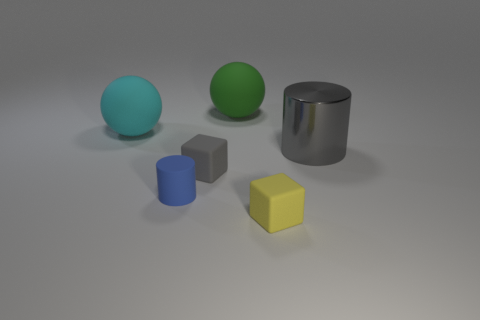Add 4 small matte cylinders. How many objects exist? 10 Subtract all blocks. How many objects are left? 4 Subtract all yellow rubber cylinders. Subtract all gray metal objects. How many objects are left? 5 Add 5 big green things. How many big green things are left? 6 Add 5 small brown blocks. How many small brown blocks exist? 5 Subtract 0 brown spheres. How many objects are left? 6 Subtract all blue cylinders. Subtract all red balls. How many cylinders are left? 1 